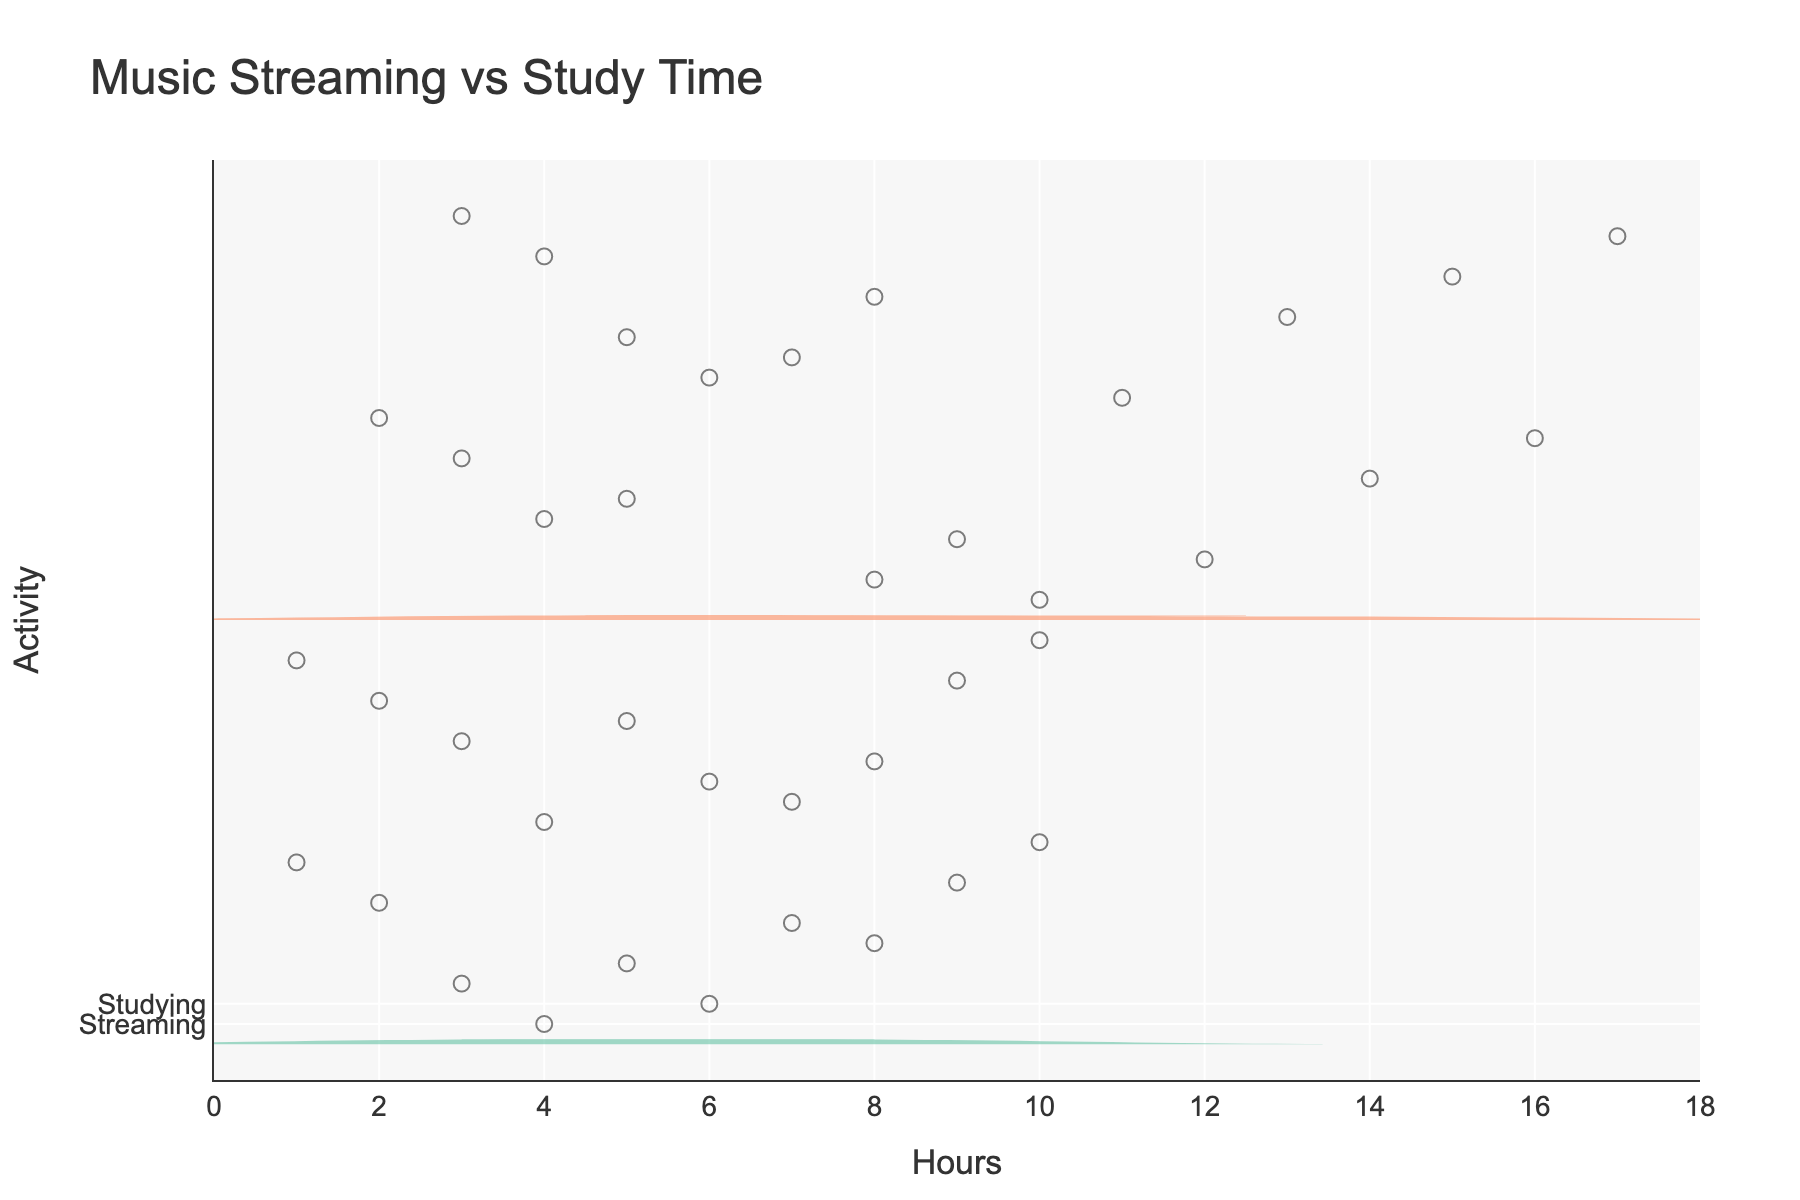What is the title of the chart? The title is found at the top of the chart, centered, and is usually in a larger or bold font.
Answer: Music Streaming vs Study Time What is the x-axis title? The x-axis title is located along the horizontal axis at the bottom of the chart and provides a label or description for the data on this axis.
Answer: Hours What is the range of the x-axis? To find the range, look at the values displayed along the horizontal axis. The chart's ticks and the axis ends indicate the minimum and maximum values.
Answer: 0 to 18 Which activity shows data with a higher range of hours? Compare the length of the horizontal distribution for both activities. Streaming hours range from about 1 to 10, while study hours range from about 2 to 17.
Answer: Study How many students spend more than 8 hours streaming music? Look at the jittered points on the streaming hours distribution to see how many are positioned at x > 8. Count the dots.
Answer: 4 Are there more students spending fewer than 5 hours studying or streaming music? Compare the number of jittered points below the 5-hour mark in both distributions.
Answer: Streaming What is the mean line for studying hours? The mean line can be identified as a horizontal line crossing the violin plot. The exact value is found by looking at where this line intersects the x-axis in the studying hours section.
Answer: Approximately 10 hours Which activity has a greater concentration of data points near the lower end of the scale? Examine the density and spread of the violin plots and the clustering of jittered points. Streaming hours are more concentrated toward the lower end compared to study hours.
Answer: Streaming How many students study more than 10 hours a day? Examine the study hours side of the chart and count the number of jittered points above the 10-hour mark.
Answer: 5 Is there a student who spends the maximum time both streaming and studying? Check the jittered points on both plots to see if the maximum streaming and studying values (which are 10 and 17 hours, respectively) align for the same data point.
Answer: No 